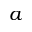Convert formula to latex. <formula><loc_0><loc_0><loc_500><loc_500>a</formula> 